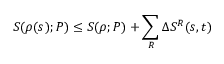Convert formula to latex. <formula><loc_0><loc_0><loc_500><loc_500>S ( \rho ( s ) ; P ) \leq S ( \rho ; P ) + \sum _ { R } \Delta S ^ { R } ( s , t )</formula> 